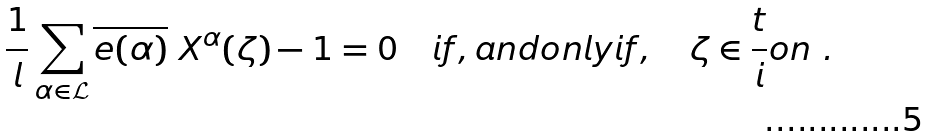Convert formula to latex. <formula><loc_0><loc_0><loc_500><loc_500>\frac { 1 } { l } \sum _ { \alpha \in { \mathcal { L } } } \overline { e ( \alpha ) } \ X ^ { \alpha } ( \zeta ) - 1 = 0 \quad i f , a n d o n l y i f , \quad \zeta \in \frac { t } { i } o n \ .</formula> 